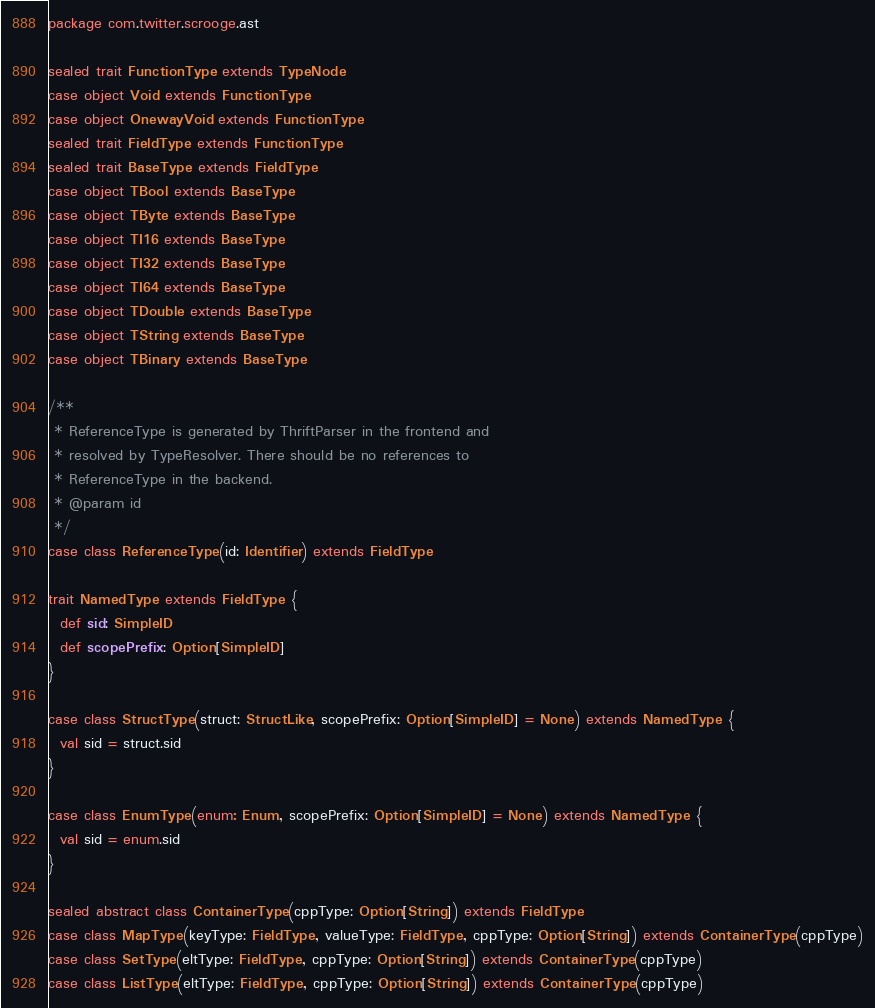Convert code to text. <code><loc_0><loc_0><loc_500><loc_500><_Scala_>package com.twitter.scrooge.ast

sealed trait FunctionType extends TypeNode
case object Void extends FunctionType
case object OnewayVoid extends FunctionType
sealed trait FieldType extends FunctionType
sealed trait BaseType extends FieldType
case object TBool extends BaseType
case object TByte extends BaseType
case object TI16 extends BaseType
case object TI32 extends BaseType
case object TI64 extends BaseType
case object TDouble extends BaseType
case object TString extends BaseType
case object TBinary extends BaseType

/**
 * ReferenceType is generated by ThriftParser in the frontend and
 * resolved by TypeResolver. There should be no references to
 * ReferenceType in the backend.
 * @param id
 */
case class ReferenceType(id: Identifier) extends FieldType

trait NamedType extends FieldType {
  def sid: SimpleID
  def scopePrefix: Option[SimpleID]
}

case class StructType(struct: StructLike, scopePrefix: Option[SimpleID] = None) extends NamedType {
  val sid = struct.sid
}

case class EnumType(enum: Enum, scopePrefix: Option[SimpleID] = None) extends NamedType {
  val sid = enum.sid
}

sealed abstract class ContainerType(cppType: Option[String]) extends FieldType
case class MapType(keyType: FieldType, valueType: FieldType, cppType: Option[String]) extends ContainerType(cppType)
case class SetType(eltType: FieldType, cppType: Option[String]) extends ContainerType(cppType)
case class ListType(eltType: FieldType, cppType: Option[String]) extends ContainerType(cppType)
</code> 